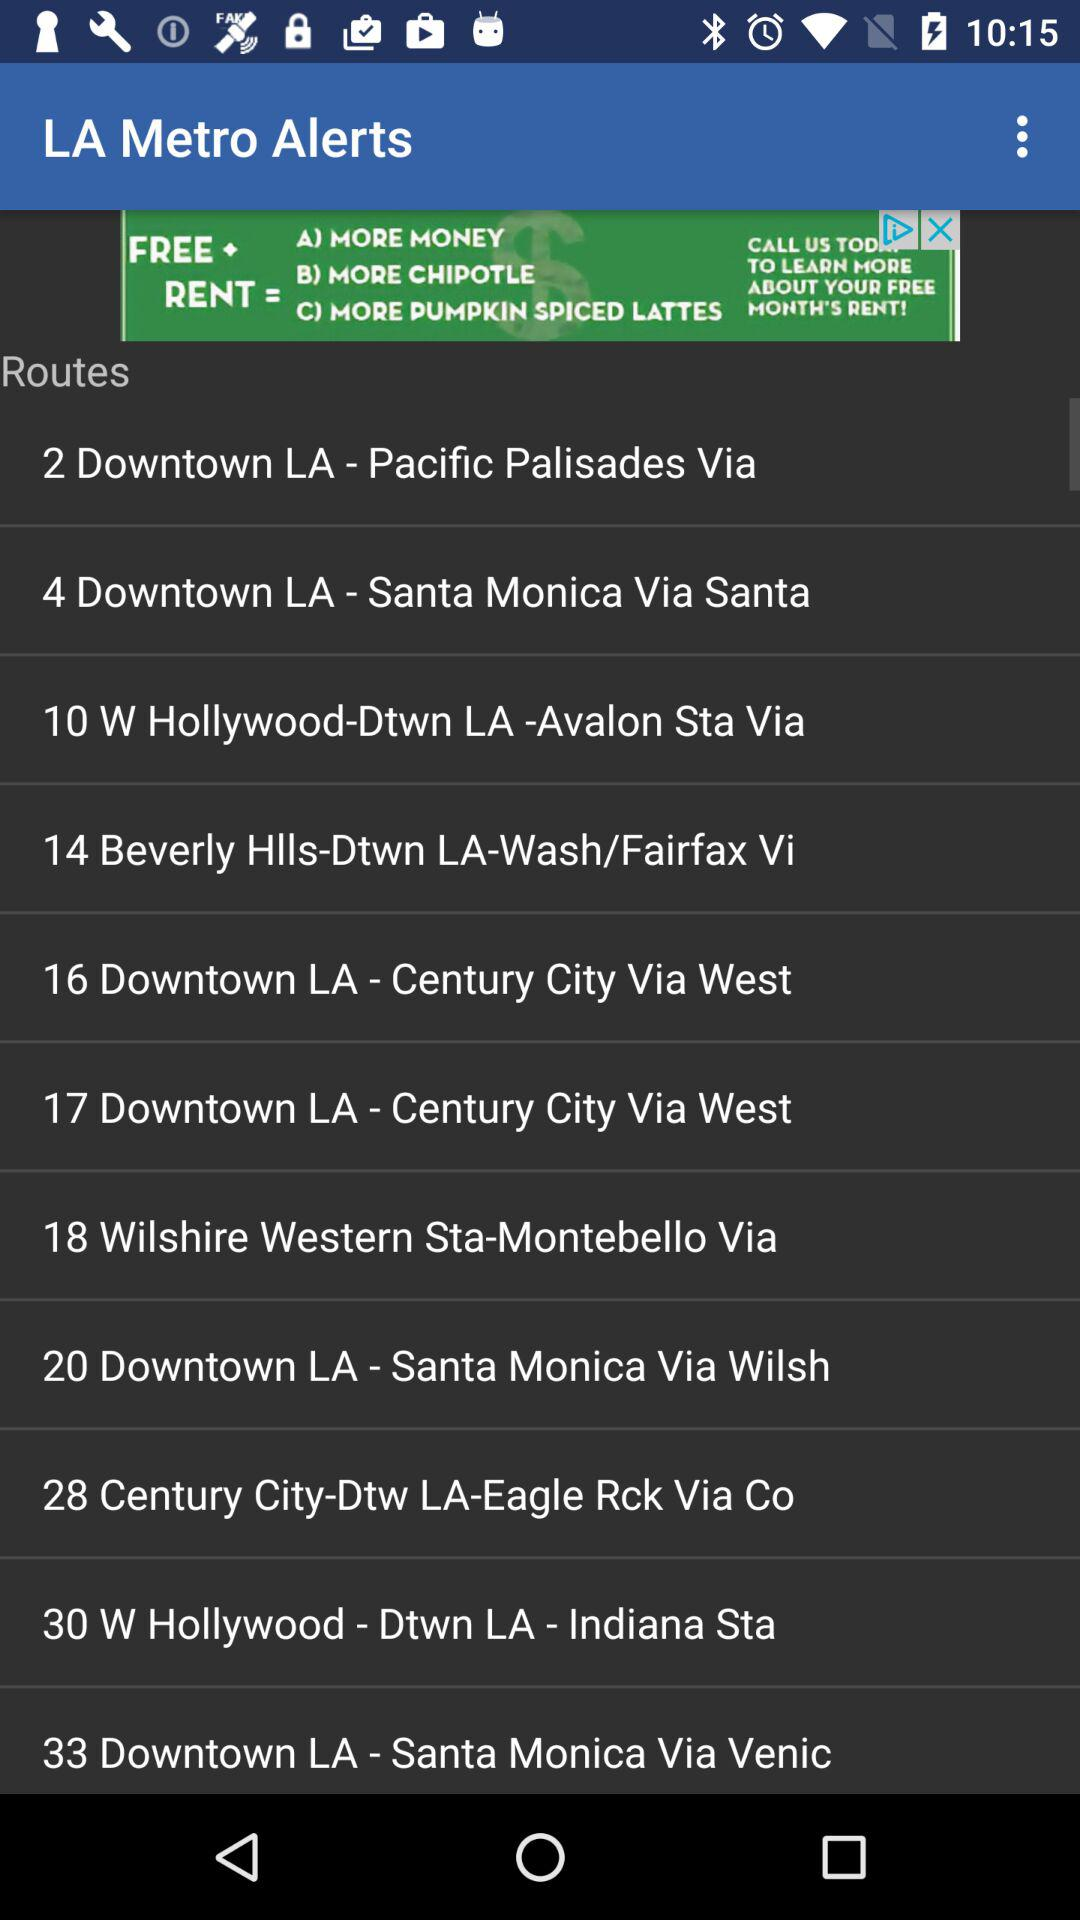Who is this application powered by?
When the provided information is insufficient, respond with <no answer>. <no answer> 